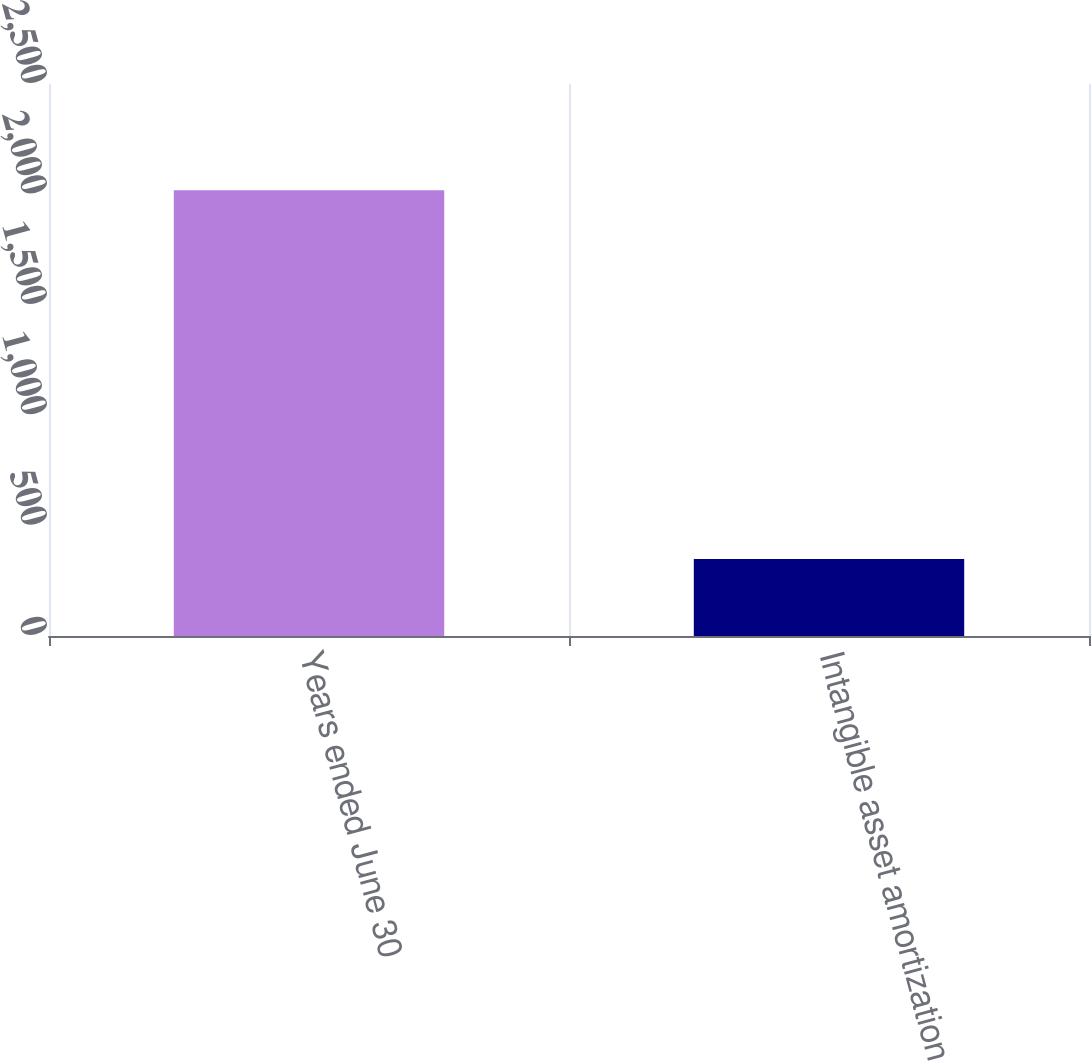Convert chart to OTSL. <chart><loc_0><loc_0><loc_500><loc_500><bar_chart><fcel>Years ended June 30<fcel>Intangible asset amortization<nl><fcel>2019<fcel>349<nl></chart> 